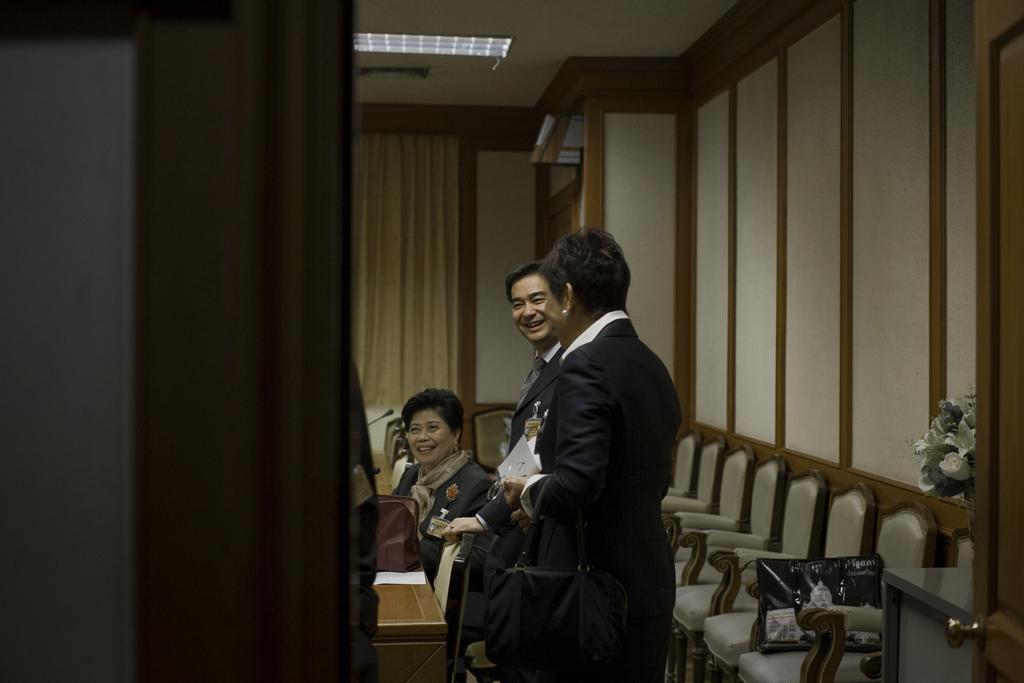In one or two sentences, can you explain what this image depicts? In the image there are two people standing and beside them there is a lady is sitting. In front of them there are mics. Behind them there are chairs. In the background there is a wall and also there is a curtain. At the top of the image there is a ceiling with lights. On the right side of the image there is a door. Behind the door there is a table with flowers bouquet. On the left side of the image there is a wall. 